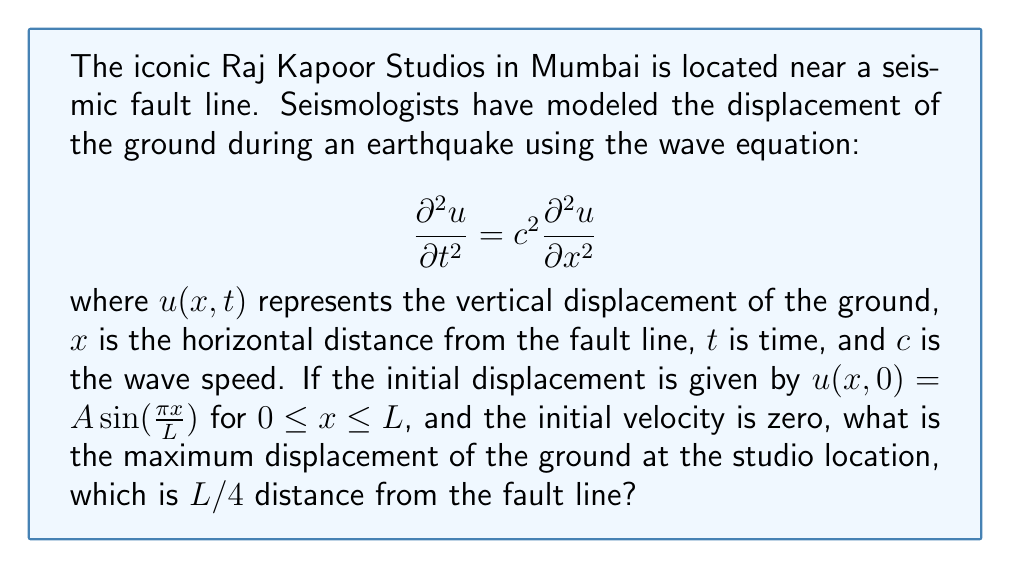Solve this math problem. Let's approach this step-by-step, reminiscent of how the great Raj Kapoor would methodically plan his scenes:

1) The general solution to the wave equation with these initial conditions is:

   $$u(x,t) = A \sin(\frac{\pi x}{L}) \cos(\frac{\pi c t}{L})$$

2) We're interested in the displacement at $x = L/4$. Substituting this into our solution:

   $$u(L/4,t) = A \sin(\frac{\pi (L/4)}{L}) \cos(\frac{\pi c t}{L})$$

3) Simplify the sine term:

   $$u(L/4,t) = A \sin(\frac{\pi}{4}) \cos(\frac{\pi c t}{L})$$

4) Recall that $\sin(\frac{\pi}{4}) = \frac{\sqrt{2}}{2}$:

   $$u(L/4,t) = A \frac{\sqrt{2}}{2} \cos(\frac{\pi c t}{L})$$

5) The cosine function oscillates between -1 and 1. Therefore, the maximum displacement occurs when $\cos(\frac{\pi c t}{L}) = \pm 1$.

6) At this maximum, the displacement is:

   $$u_{max}(L/4) = \pm A \frac{\sqrt{2}}{2}$$

7) The absolute maximum displacement is thus:

   $$|u_{max}(L/4)| = A \frac{\sqrt{2}}{2}$$

This result shows that the maximum displacement at the studio is a fraction of the initial amplitude $A$, scaled by $\frac{\sqrt{2}}{2}$.
Answer: $A \frac{\sqrt{2}}{2}$ 